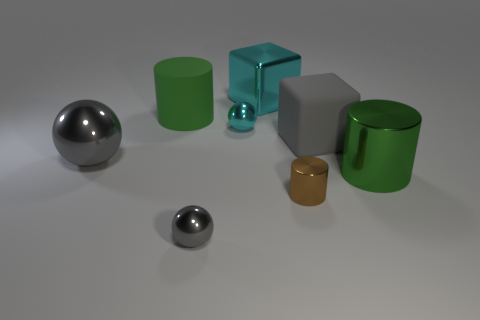What material is the small brown cylinder?
Ensure brevity in your answer.  Metal. Do the cube that is to the right of the big cyan thing and the tiny gray sphere have the same material?
Your answer should be very brief. No. Is the number of small metallic balls behind the large shiny sphere less than the number of big rubber cubes?
Keep it short and to the point. No. There is another sphere that is the same size as the cyan metal sphere; what color is it?
Offer a terse response. Gray. How many green things have the same shape as the small brown object?
Keep it short and to the point. 2. There is a block that is in front of the big cyan block; what is its color?
Offer a very short reply. Gray. What number of shiny objects are small red cylinders or tiny gray things?
Give a very brief answer. 1. What is the shape of the matte thing that is the same color as the big shiny sphere?
Your answer should be very brief. Cube. What number of objects have the same size as the green metal cylinder?
Your answer should be very brief. 4. There is a big shiny object that is both in front of the big gray block and to the right of the big metal ball; what is its color?
Make the answer very short. Green. 